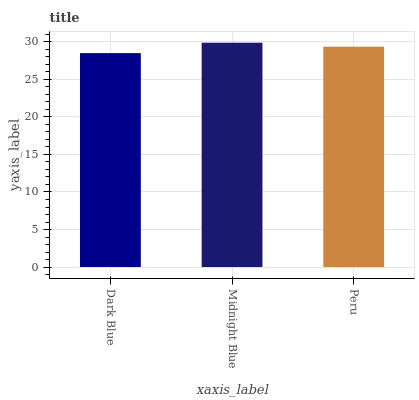Is Dark Blue the minimum?
Answer yes or no. Yes. Is Midnight Blue the maximum?
Answer yes or no. Yes. Is Peru the minimum?
Answer yes or no. No. Is Peru the maximum?
Answer yes or no. No. Is Midnight Blue greater than Peru?
Answer yes or no. Yes. Is Peru less than Midnight Blue?
Answer yes or no. Yes. Is Peru greater than Midnight Blue?
Answer yes or no. No. Is Midnight Blue less than Peru?
Answer yes or no. No. Is Peru the high median?
Answer yes or no. Yes. Is Peru the low median?
Answer yes or no. Yes. Is Midnight Blue the high median?
Answer yes or no. No. Is Midnight Blue the low median?
Answer yes or no. No. 